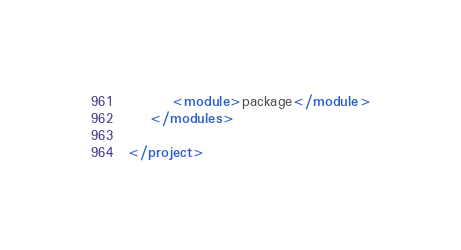<code> <loc_0><loc_0><loc_500><loc_500><_XML_>		<module>package</module>
	</modules>

</project>
</code> 